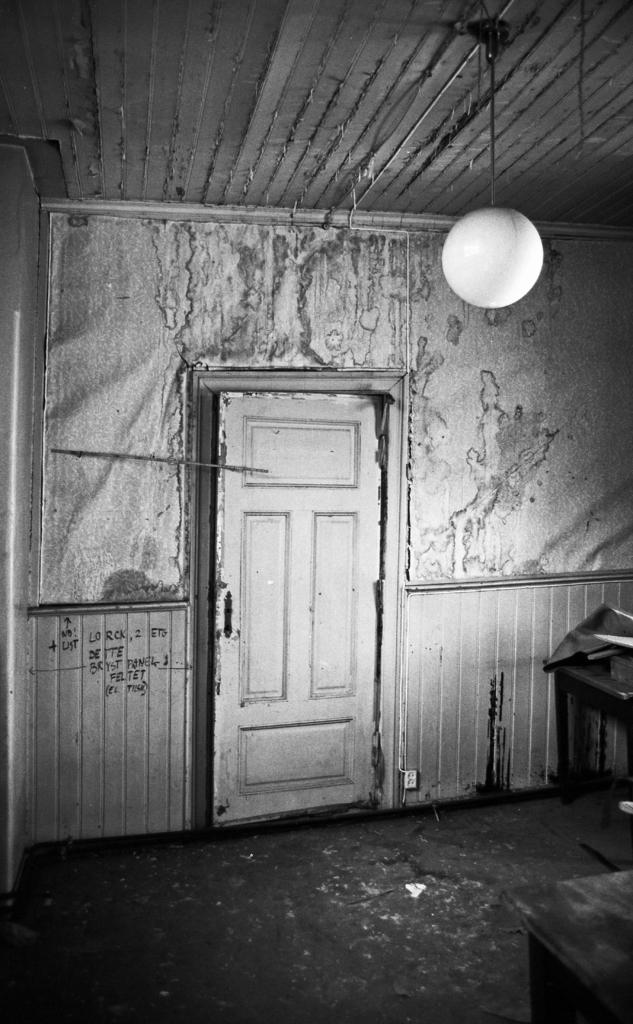What is the color scheme of the image? The image is in black and white. What architectural feature can be seen in the image? There is a door in the image. What else is present in the image besides the door? There is a wall in the image. Is there any source of light visible in the image? Yes, there is a light in the image. What type of ball is being used for the voyage in the image? There is no ball or voyage present in the image; it only features a door, a wall, and a light. 